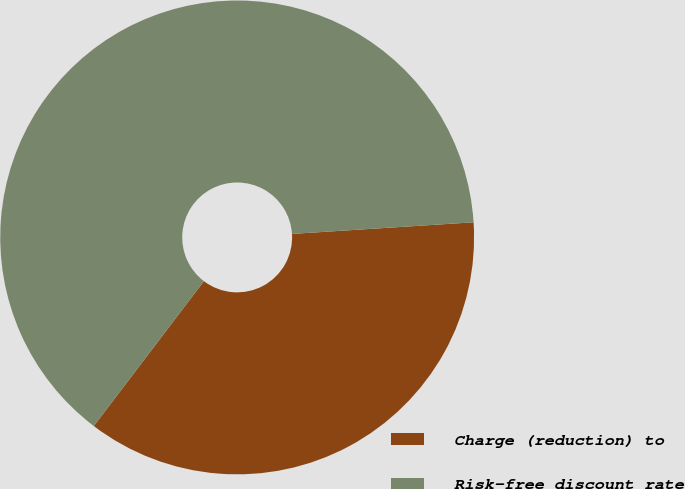Convert chart to OTSL. <chart><loc_0><loc_0><loc_500><loc_500><pie_chart><fcel>Charge (reduction) to<fcel>Risk-free discount rate<nl><fcel>36.36%<fcel>63.64%<nl></chart> 